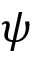Convert formula to latex. <formula><loc_0><loc_0><loc_500><loc_500>\psi</formula> 